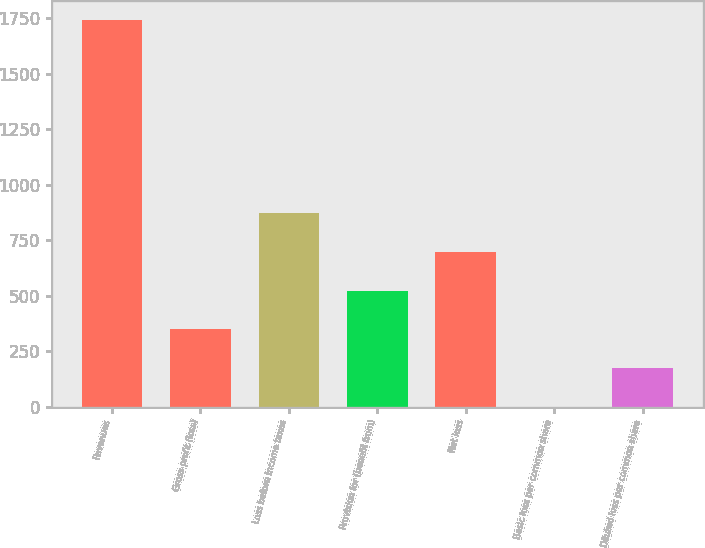<chart> <loc_0><loc_0><loc_500><loc_500><bar_chart><fcel>Revenues<fcel>Gross profit (loss)<fcel>Loss before income taxes<fcel>Provision for (benefit from)<fcel>Net loss<fcel>Basic loss per common share<fcel>Diluted loss per common share<nl><fcel>1742.6<fcel>348.85<fcel>871.51<fcel>523.07<fcel>697.29<fcel>0.41<fcel>174.63<nl></chart> 